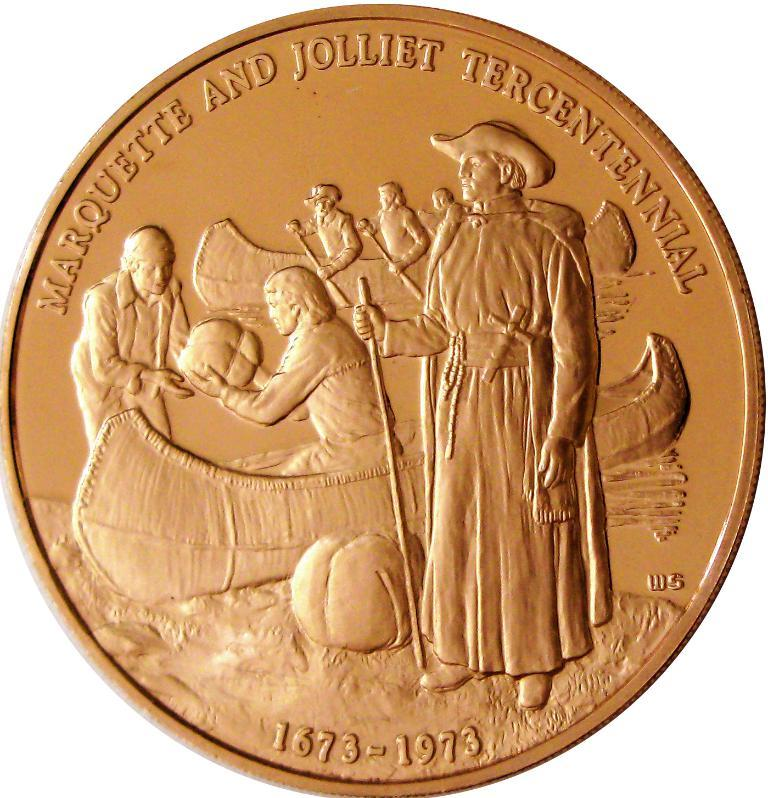<image>
Describe the image concisely. A coin engraved with Marquette and Jolliet Tercentenniel with the dates 1673-1973 